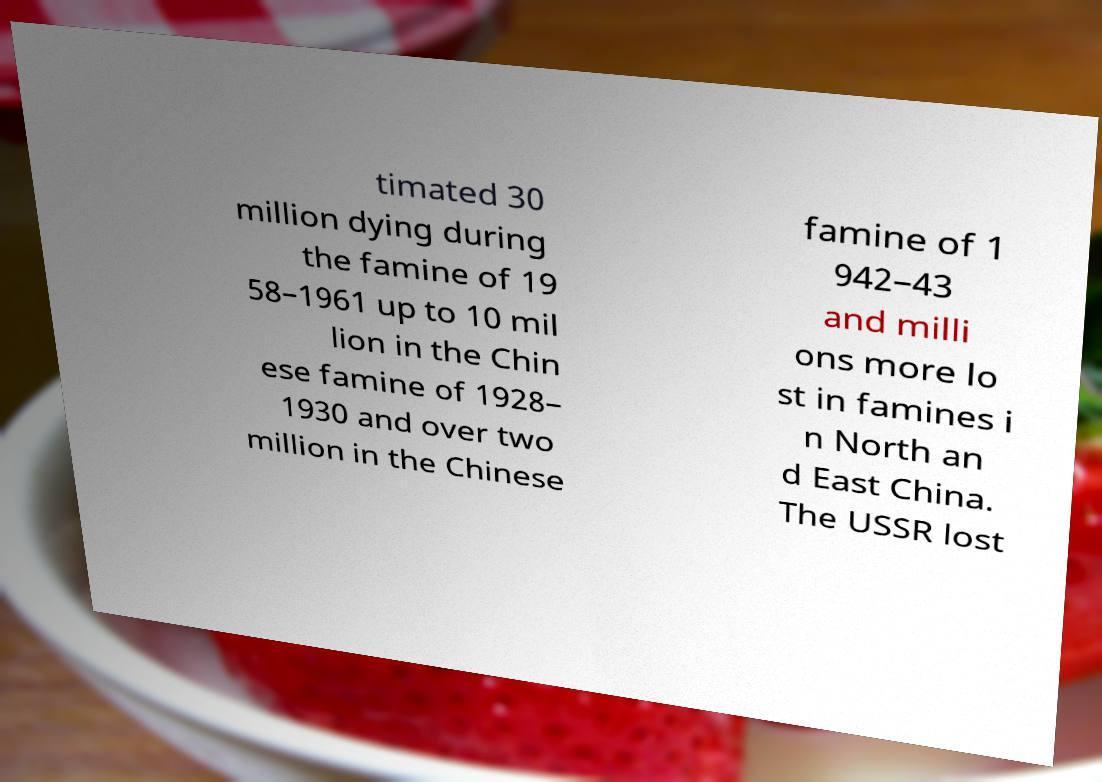I need the written content from this picture converted into text. Can you do that? timated 30 million dying during the famine of 19 58–1961 up to 10 mil lion in the Chin ese famine of 1928– 1930 and over two million in the Chinese famine of 1 942–43 and milli ons more lo st in famines i n North an d East China. The USSR lost 